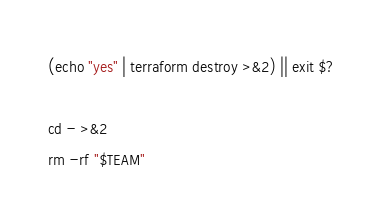Convert code to text. <code><loc_0><loc_0><loc_500><loc_500><_Bash_>
(echo "yes" | terraform destroy >&2) || exit $?

cd - >&2
rm -rf "$TEAM"

</code> 